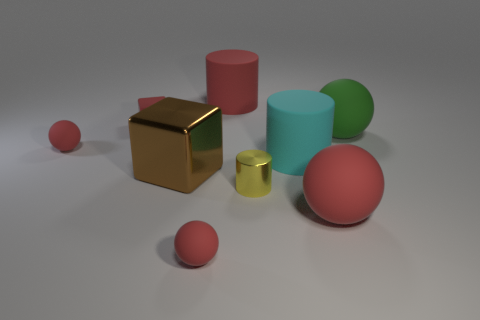What number of rubber things are the same color as the tiny shiny object?
Your response must be concise. 0. There is a red object on the right side of the large red cylinder; is it the same shape as the brown metallic thing?
Your answer should be very brief. No. The large red rubber thing behind the large rubber cylinder that is in front of the large rubber thing on the left side of the cyan rubber cylinder is what shape?
Keep it short and to the point. Cylinder. The cyan thing is what size?
Make the answer very short. Large. There is another big ball that is made of the same material as the big green sphere; what is its color?
Your response must be concise. Red. How many small gray cubes are made of the same material as the large green object?
Make the answer very short. 0. There is a small block; is its color the same as the big matte cylinder that is behind the large cyan thing?
Provide a short and direct response. Yes. What is the color of the cylinder in front of the matte cylinder that is to the right of the big red cylinder?
Your answer should be very brief. Yellow. The other metal thing that is the same size as the cyan thing is what color?
Provide a succinct answer. Brown. Are there any tiny matte things of the same shape as the large brown metallic object?
Provide a short and direct response. Yes. 